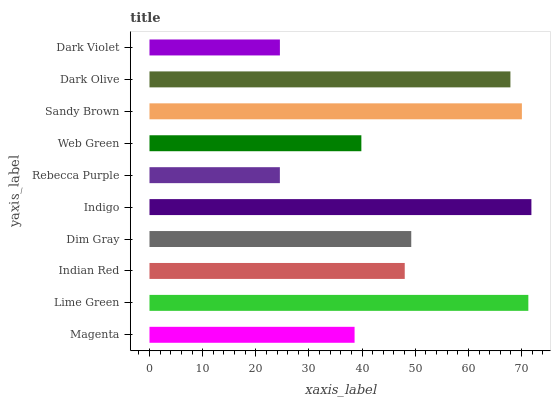Is Rebecca Purple the minimum?
Answer yes or no. Yes. Is Indigo the maximum?
Answer yes or no. Yes. Is Lime Green the minimum?
Answer yes or no. No. Is Lime Green the maximum?
Answer yes or no. No. Is Lime Green greater than Magenta?
Answer yes or no. Yes. Is Magenta less than Lime Green?
Answer yes or no. Yes. Is Magenta greater than Lime Green?
Answer yes or no. No. Is Lime Green less than Magenta?
Answer yes or no. No. Is Dim Gray the high median?
Answer yes or no. Yes. Is Indian Red the low median?
Answer yes or no. Yes. Is Indian Red the high median?
Answer yes or no. No. Is Dark Olive the low median?
Answer yes or no. No. 